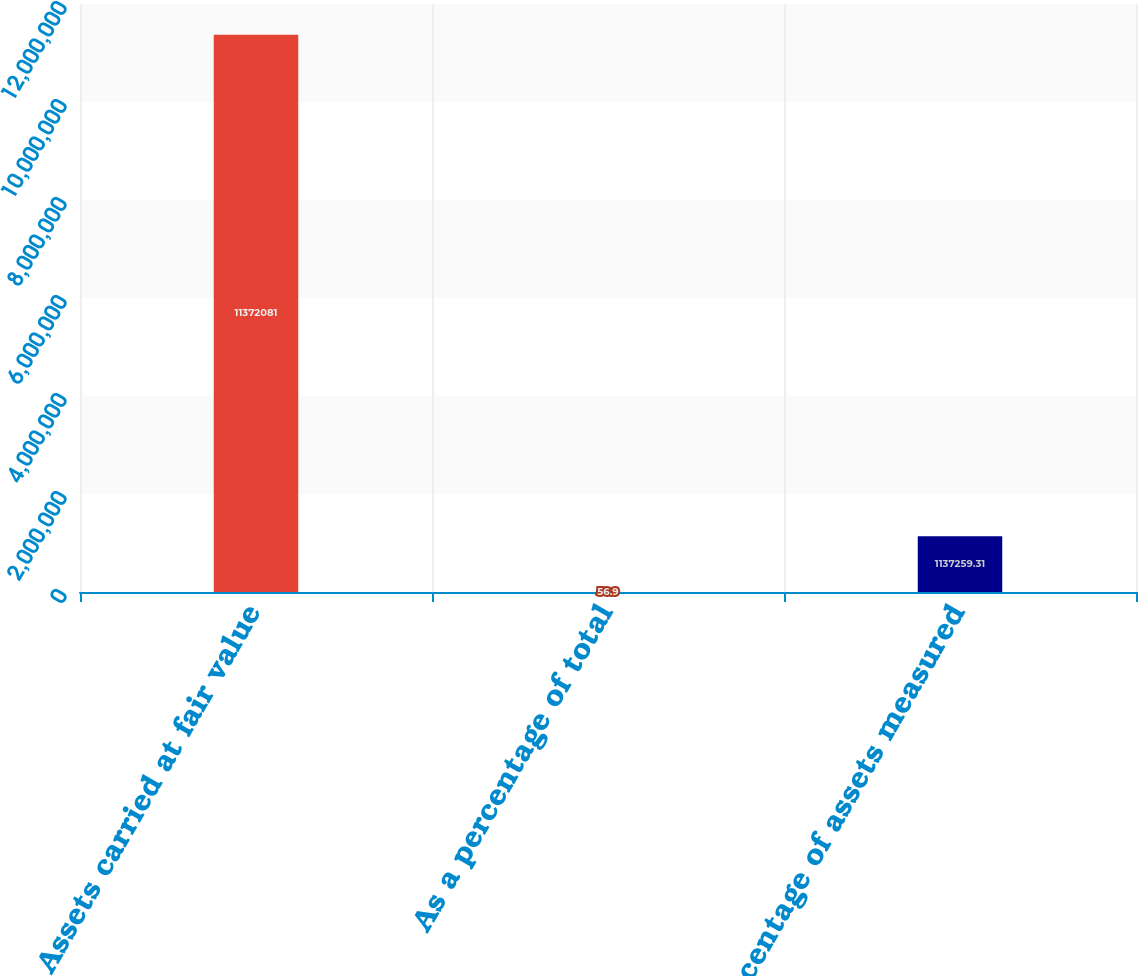<chart> <loc_0><loc_0><loc_500><loc_500><bar_chart><fcel>Assets carried at fair value<fcel>As a percentage of total<fcel>Percentage of assets measured<nl><fcel>1.13721e+07<fcel>56.9<fcel>1.13726e+06<nl></chart> 